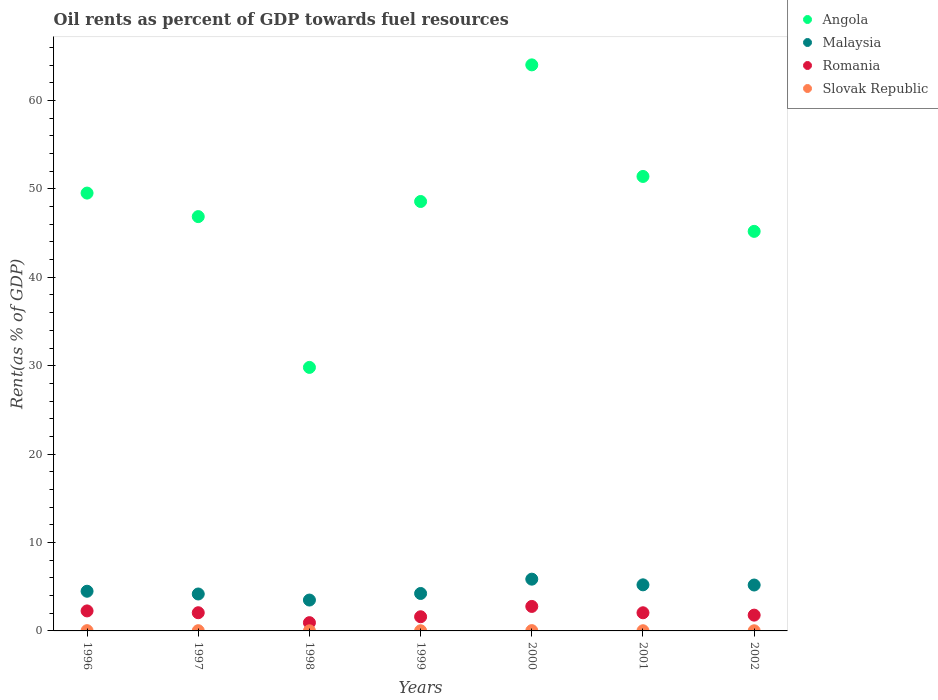How many different coloured dotlines are there?
Provide a short and direct response. 4. What is the oil rent in Romania in 1996?
Make the answer very short. 2.26. Across all years, what is the maximum oil rent in Malaysia?
Your answer should be very brief. 5.85. Across all years, what is the minimum oil rent in Slovak Republic?
Your response must be concise. 0.01. In which year was the oil rent in Angola minimum?
Your answer should be compact. 1998. What is the total oil rent in Romania in the graph?
Give a very brief answer. 13.47. What is the difference between the oil rent in Malaysia in 1997 and that in 1999?
Your answer should be compact. -0.06. What is the difference between the oil rent in Angola in 2002 and the oil rent in Slovak Republic in 1996?
Your response must be concise. 45.17. What is the average oil rent in Malaysia per year?
Provide a short and direct response. 4.66. In the year 2002, what is the difference between the oil rent in Romania and oil rent in Malaysia?
Provide a short and direct response. -3.41. In how many years, is the oil rent in Angola greater than 40 %?
Provide a short and direct response. 6. What is the ratio of the oil rent in Malaysia in 1998 to that in 2000?
Keep it short and to the point. 0.6. Is the difference between the oil rent in Romania in 1999 and 2002 greater than the difference between the oil rent in Malaysia in 1999 and 2002?
Provide a short and direct response. Yes. What is the difference between the highest and the second highest oil rent in Slovak Republic?
Offer a terse response. 0. What is the difference between the highest and the lowest oil rent in Slovak Republic?
Offer a very short reply. 0.02. Is it the case that in every year, the sum of the oil rent in Slovak Republic and oil rent in Romania  is greater than the sum of oil rent in Malaysia and oil rent in Angola?
Offer a terse response. No. Does the oil rent in Slovak Republic monotonically increase over the years?
Offer a very short reply. No. Is the oil rent in Slovak Republic strictly less than the oil rent in Romania over the years?
Provide a short and direct response. Yes. How many dotlines are there?
Ensure brevity in your answer.  4. Are the values on the major ticks of Y-axis written in scientific E-notation?
Offer a very short reply. No. Does the graph contain any zero values?
Offer a terse response. No. How many legend labels are there?
Provide a short and direct response. 4. What is the title of the graph?
Your response must be concise. Oil rents as percent of GDP towards fuel resources. Does "Iraq" appear as one of the legend labels in the graph?
Provide a succinct answer. No. What is the label or title of the X-axis?
Your answer should be very brief. Years. What is the label or title of the Y-axis?
Give a very brief answer. Rent(as % of GDP). What is the Rent(as % of GDP) of Angola in 1996?
Ensure brevity in your answer.  49.53. What is the Rent(as % of GDP) in Malaysia in 1996?
Offer a very short reply. 4.49. What is the Rent(as % of GDP) in Romania in 1996?
Your response must be concise. 2.26. What is the Rent(as % of GDP) in Slovak Republic in 1996?
Make the answer very short. 0.03. What is the Rent(as % of GDP) of Angola in 1997?
Provide a short and direct response. 46.87. What is the Rent(as % of GDP) in Malaysia in 1997?
Your answer should be very brief. 4.18. What is the Rent(as % of GDP) in Romania in 1997?
Your response must be concise. 2.06. What is the Rent(as % of GDP) of Slovak Republic in 1997?
Give a very brief answer. 0.03. What is the Rent(as % of GDP) in Angola in 1998?
Offer a terse response. 29.81. What is the Rent(as % of GDP) of Malaysia in 1998?
Your answer should be very brief. 3.49. What is the Rent(as % of GDP) in Romania in 1998?
Your answer should be compact. 0.93. What is the Rent(as % of GDP) of Slovak Republic in 1998?
Ensure brevity in your answer.  0.01. What is the Rent(as % of GDP) in Angola in 1999?
Ensure brevity in your answer.  48.58. What is the Rent(as % of GDP) of Malaysia in 1999?
Make the answer very short. 4.24. What is the Rent(as % of GDP) in Romania in 1999?
Your answer should be very brief. 1.6. What is the Rent(as % of GDP) in Slovak Republic in 1999?
Keep it short and to the point. 0.02. What is the Rent(as % of GDP) of Angola in 2000?
Offer a very short reply. 64.03. What is the Rent(as % of GDP) of Malaysia in 2000?
Give a very brief answer. 5.85. What is the Rent(as % of GDP) of Romania in 2000?
Offer a terse response. 2.77. What is the Rent(as % of GDP) of Slovak Republic in 2000?
Your answer should be very brief. 0.03. What is the Rent(as % of GDP) of Angola in 2001?
Make the answer very short. 51.41. What is the Rent(as % of GDP) in Malaysia in 2001?
Ensure brevity in your answer.  5.21. What is the Rent(as % of GDP) in Romania in 2001?
Make the answer very short. 2.05. What is the Rent(as % of GDP) of Slovak Republic in 2001?
Keep it short and to the point. 0.02. What is the Rent(as % of GDP) of Angola in 2002?
Make the answer very short. 45.2. What is the Rent(as % of GDP) in Malaysia in 2002?
Keep it short and to the point. 5.19. What is the Rent(as % of GDP) in Romania in 2002?
Keep it short and to the point. 1.79. What is the Rent(as % of GDP) of Slovak Republic in 2002?
Offer a terse response. 0.02. Across all years, what is the maximum Rent(as % of GDP) in Angola?
Keep it short and to the point. 64.03. Across all years, what is the maximum Rent(as % of GDP) of Malaysia?
Offer a very short reply. 5.85. Across all years, what is the maximum Rent(as % of GDP) of Romania?
Your response must be concise. 2.77. Across all years, what is the maximum Rent(as % of GDP) of Slovak Republic?
Provide a short and direct response. 0.03. Across all years, what is the minimum Rent(as % of GDP) of Angola?
Offer a terse response. 29.81. Across all years, what is the minimum Rent(as % of GDP) of Malaysia?
Provide a succinct answer. 3.49. Across all years, what is the minimum Rent(as % of GDP) in Romania?
Make the answer very short. 0.93. Across all years, what is the minimum Rent(as % of GDP) of Slovak Republic?
Your answer should be compact. 0.01. What is the total Rent(as % of GDP) in Angola in the graph?
Keep it short and to the point. 335.41. What is the total Rent(as % of GDP) of Malaysia in the graph?
Your response must be concise. 32.65. What is the total Rent(as % of GDP) in Romania in the graph?
Your response must be concise. 13.47. What is the total Rent(as % of GDP) in Slovak Republic in the graph?
Your answer should be very brief. 0.16. What is the difference between the Rent(as % of GDP) in Angola in 1996 and that in 1997?
Give a very brief answer. 2.66. What is the difference between the Rent(as % of GDP) in Malaysia in 1996 and that in 1997?
Your answer should be compact. 0.31. What is the difference between the Rent(as % of GDP) of Romania in 1996 and that in 1997?
Make the answer very short. 0.21. What is the difference between the Rent(as % of GDP) of Slovak Republic in 1996 and that in 1997?
Ensure brevity in your answer.  0. What is the difference between the Rent(as % of GDP) in Angola in 1996 and that in 1998?
Offer a terse response. 19.72. What is the difference between the Rent(as % of GDP) in Malaysia in 1996 and that in 1998?
Ensure brevity in your answer.  1. What is the difference between the Rent(as % of GDP) of Romania in 1996 and that in 1998?
Provide a short and direct response. 1.33. What is the difference between the Rent(as % of GDP) of Slovak Republic in 1996 and that in 1998?
Provide a succinct answer. 0.02. What is the difference between the Rent(as % of GDP) of Angola in 1996 and that in 1999?
Make the answer very short. 0.95. What is the difference between the Rent(as % of GDP) of Malaysia in 1996 and that in 1999?
Provide a short and direct response. 0.25. What is the difference between the Rent(as % of GDP) in Romania in 1996 and that in 1999?
Make the answer very short. 0.66. What is the difference between the Rent(as % of GDP) of Slovak Republic in 1996 and that in 1999?
Your response must be concise. 0.01. What is the difference between the Rent(as % of GDP) of Angola in 1996 and that in 2000?
Give a very brief answer. -14.5. What is the difference between the Rent(as % of GDP) in Malaysia in 1996 and that in 2000?
Ensure brevity in your answer.  -1.37. What is the difference between the Rent(as % of GDP) in Romania in 1996 and that in 2000?
Ensure brevity in your answer.  -0.51. What is the difference between the Rent(as % of GDP) of Slovak Republic in 1996 and that in 2000?
Keep it short and to the point. -0. What is the difference between the Rent(as % of GDP) in Angola in 1996 and that in 2001?
Your response must be concise. -1.88. What is the difference between the Rent(as % of GDP) of Malaysia in 1996 and that in 2001?
Make the answer very short. -0.72. What is the difference between the Rent(as % of GDP) of Romania in 1996 and that in 2001?
Provide a short and direct response. 0.21. What is the difference between the Rent(as % of GDP) of Slovak Republic in 1996 and that in 2001?
Give a very brief answer. 0.01. What is the difference between the Rent(as % of GDP) in Angola in 1996 and that in 2002?
Make the answer very short. 4.33. What is the difference between the Rent(as % of GDP) in Malaysia in 1996 and that in 2002?
Your response must be concise. -0.7. What is the difference between the Rent(as % of GDP) of Romania in 1996 and that in 2002?
Offer a very short reply. 0.48. What is the difference between the Rent(as % of GDP) in Slovak Republic in 1996 and that in 2002?
Your answer should be very brief. 0.01. What is the difference between the Rent(as % of GDP) of Angola in 1997 and that in 1998?
Offer a very short reply. 17.06. What is the difference between the Rent(as % of GDP) of Malaysia in 1997 and that in 1998?
Ensure brevity in your answer.  0.69. What is the difference between the Rent(as % of GDP) in Romania in 1997 and that in 1998?
Your answer should be very brief. 1.12. What is the difference between the Rent(as % of GDP) of Slovak Republic in 1997 and that in 1998?
Provide a short and direct response. 0.01. What is the difference between the Rent(as % of GDP) of Angola in 1997 and that in 1999?
Ensure brevity in your answer.  -1.71. What is the difference between the Rent(as % of GDP) in Malaysia in 1997 and that in 1999?
Your answer should be very brief. -0.06. What is the difference between the Rent(as % of GDP) of Romania in 1997 and that in 1999?
Provide a succinct answer. 0.46. What is the difference between the Rent(as % of GDP) of Slovak Republic in 1997 and that in 1999?
Ensure brevity in your answer.  0.01. What is the difference between the Rent(as % of GDP) of Angola in 1997 and that in 2000?
Your answer should be compact. -17.16. What is the difference between the Rent(as % of GDP) of Malaysia in 1997 and that in 2000?
Your answer should be compact. -1.68. What is the difference between the Rent(as % of GDP) of Romania in 1997 and that in 2000?
Provide a short and direct response. -0.71. What is the difference between the Rent(as % of GDP) of Slovak Republic in 1997 and that in 2000?
Your response must be concise. -0.01. What is the difference between the Rent(as % of GDP) in Angola in 1997 and that in 2001?
Offer a very short reply. -4.54. What is the difference between the Rent(as % of GDP) in Malaysia in 1997 and that in 2001?
Provide a short and direct response. -1.04. What is the difference between the Rent(as % of GDP) in Romania in 1997 and that in 2001?
Offer a very short reply. 0. What is the difference between the Rent(as % of GDP) in Slovak Republic in 1997 and that in 2001?
Offer a terse response. 0. What is the difference between the Rent(as % of GDP) of Angola in 1997 and that in 2002?
Keep it short and to the point. 1.67. What is the difference between the Rent(as % of GDP) in Malaysia in 1997 and that in 2002?
Your answer should be compact. -1.02. What is the difference between the Rent(as % of GDP) in Romania in 1997 and that in 2002?
Provide a short and direct response. 0.27. What is the difference between the Rent(as % of GDP) of Slovak Republic in 1997 and that in 2002?
Keep it short and to the point. 0.01. What is the difference between the Rent(as % of GDP) of Angola in 1998 and that in 1999?
Make the answer very short. -18.77. What is the difference between the Rent(as % of GDP) of Malaysia in 1998 and that in 1999?
Ensure brevity in your answer.  -0.74. What is the difference between the Rent(as % of GDP) in Romania in 1998 and that in 1999?
Offer a very short reply. -0.67. What is the difference between the Rent(as % of GDP) in Slovak Republic in 1998 and that in 1999?
Make the answer very short. -0.01. What is the difference between the Rent(as % of GDP) in Angola in 1998 and that in 2000?
Give a very brief answer. -34.22. What is the difference between the Rent(as % of GDP) of Malaysia in 1998 and that in 2000?
Make the answer very short. -2.36. What is the difference between the Rent(as % of GDP) of Romania in 1998 and that in 2000?
Your answer should be very brief. -1.83. What is the difference between the Rent(as % of GDP) of Slovak Republic in 1998 and that in 2000?
Keep it short and to the point. -0.02. What is the difference between the Rent(as % of GDP) of Angola in 1998 and that in 2001?
Make the answer very short. -21.6. What is the difference between the Rent(as % of GDP) of Malaysia in 1998 and that in 2001?
Ensure brevity in your answer.  -1.72. What is the difference between the Rent(as % of GDP) in Romania in 1998 and that in 2001?
Provide a short and direct response. -1.12. What is the difference between the Rent(as % of GDP) in Slovak Republic in 1998 and that in 2001?
Offer a very short reply. -0.01. What is the difference between the Rent(as % of GDP) of Angola in 1998 and that in 2002?
Your response must be concise. -15.39. What is the difference between the Rent(as % of GDP) of Malaysia in 1998 and that in 2002?
Ensure brevity in your answer.  -1.7. What is the difference between the Rent(as % of GDP) of Romania in 1998 and that in 2002?
Give a very brief answer. -0.85. What is the difference between the Rent(as % of GDP) in Slovak Republic in 1998 and that in 2002?
Make the answer very short. -0.01. What is the difference between the Rent(as % of GDP) in Angola in 1999 and that in 2000?
Give a very brief answer. -15.45. What is the difference between the Rent(as % of GDP) of Malaysia in 1999 and that in 2000?
Your answer should be very brief. -1.62. What is the difference between the Rent(as % of GDP) of Romania in 1999 and that in 2000?
Offer a very short reply. -1.17. What is the difference between the Rent(as % of GDP) of Slovak Republic in 1999 and that in 2000?
Provide a short and direct response. -0.01. What is the difference between the Rent(as % of GDP) of Angola in 1999 and that in 2001?
Your response must be concise. -2.83. What is the difference between the Rent(as % of GDP) of Malaysia in 1999 and that in 2001?
Provide a short and direct response. -0.98. What is the difference between the Rent(as % of GDP) in Romania in 1999 and that in 2001?
Provide a succinct answer. -0.45. What is the difference between the Rent(as % of GDP) of Slovak Republic in 1999 and that in 2001?
Ensure brevity in your answer.  -0. What is the difference between the Rent(as % of GDP) of Angola in 1999 and that in 2002?
Provide a succinct answer. 3.38. What is the difference between the Rent(as % of GDP) in Malaysia in 1999 and that in 2002?
Give a very brief answer. -0.96. What is the difference between the Rent(as % of GDP) of Romania in 1999 and that in 2002?
Provide a short and direct response. -0.18. What is the difference between the Rent(as % of GDP) in Slovak Republic in 1999 and that in 2002?
Offer a very short reply. 0. What is the difference between the Rent(as % of GDP) in Angola in 2000 and that in 2001?
Offer a terse response. 12.62. What is the difference between the Rent(as % of GDP) of Malaysia in 2000 and that in 2001?
Your response must be concise. 0.64. What is the difference between the Rent(as % of GDP) of Romania in 2000 and that in 2001?
Provide a short and direct response. 0.72. What is the difference between the Rent(as % of GDP) of Slovak Republic in 2000 and that in 2001?
Your response must be concise. 0.01. What is the difference between the Rent(as % of GDP) in Angola in 2000 and that in 2002?
Your response must be concise. 18.83. What is the difference between the Rent(as % of GDP) in Malaysia in 2000 and that in 2002?
Offer a terse response. 0.66. What is the difference between the Rent(as % of GDP) in Romania in 2000 and that in 2002?
Keep it short and to the point. 0.98. What is the difference between the Rent(as % of GDP) of Slovak Republic in 2000 and that in 2002?
Provide a succinct answer. 0.02. What is the difference between the Rent(as % of GDP) of Angola in 2001 and that in 2002?
Provide a short and direct response. 6.21. What is the difference between the Rent(as % of GDP) of Malaysia in 2001 and that in 2002?
Your answer should be very brief. 0.02. What is the difference between the Rent(as % of GDP) of Romania in 2001 and that in 2002?
Ensure brevity in your answer.  0.27. What is the difference between the Rent(as % of GDP) of Slovak Republic in 2001 and that in 2002?
Your answer should be very brief. 0. What is the difference between the Rent(as % of GDP) in Angola in 1996 and the Rent(as % of GDP) in Malaysia in 1997?
Your answer should be very brief. 45.35. What is the difference between the Rent(as % of GDP) of Angola in 1996 and the Rent(as % of GDP) of Romania in 1997?
Your response must be concise. 47.47. What is the difference between the Rent(as % of GDP) of Angola in 1996 and the Rent(as % of GDP) of Slovak Republic in 1997?
Your answer should be very brief. 49.5. What is the difference between the Rent(as % of GDP) of Malaysia in 1996 and the Rent(as % of GDP) of Romania in 1997?
Make the answer very short. 2.43. What is the difference between the Rent(as % of GDP) of Malaysia in 1996 and the Rent(as % of GDP) of Slovak Republic in 1997?
Offer a very short reply. 4.46. What is the difference between the Rent(as % of GDP) of Romania in 1996 and the Rent(as % of GDP) of Slovak Republic in 1997?
Ensure brevity in your answer.  2.24. What is the difference between the Rent(as % of GDP) in Angola in 1996 and the Rent(as % of GDP) in Malaysia in 1998?
Keep it short and to the point. 46.03. What is the difference between the Rent(as % of GDP) of Angola in 1996 and the Rent(as % of GDP) of Romania in 1998?
Your answer should be very brief. 48.59. What is the difference between the Rent(as % of GDP) in Angola in 1996 and the Rent(as % of GDP) in Slovak Republic in 1998?
Give a very brief answer. 49.51. What is the difference between the Rent(as % of GDP) in Malaysia in 1996 and the Rent(as % of GDP) in Romania in 1998?
Make the answer very short. 3.55. What is the difference between the Rent(as % of GDP) in Malaysia in 1996 and the Rent(as % of GDP) in Slovak Republic in 1998?
Your answer should be compact. 4.48. What is the difference between the Rent(as % of GDP) in Romania in 1996 and the Rent(as % of GDP) in Slovak Republic in 1998?
Provide a succinct answer. 2.25. What is the difference between the Rent(as % of GDP) in Angola in 1996 and the Rent(as % of GDP) in Malaysia in 1999?
Your answer should be very brief. 45.29. What is the difference between the Rent(as % of GDP) of Angola in 1996 and the Rent(as % of GDP) of Romania in 1999?
Provide a short and direct response. 47.92. What is the difference between the Rent(as % of GDP) of Angola in 1996 and the Rent(as % of GDP) of Slovak Republic in 1999?
Your answer should be very brief. 49.51. What is the difference between the Rent(as % of GDP) in Malaysia in 1996 and the Rent(as % of GDP) in Romania in 1999?
Provide a succinct answer. 2.89. What is the difference between the Rent(as % of GDP) in Malaysia in 1996 and the Rent(as % of GDP) in Slovak Republic in 1999?
Provide a short and direct response. 4.47. What is the difference between the Rent(as % of GDP) in Romania in 1996 and the Rent(as % of GDP) in Slovak Republic in 1999?
Keep it short and to the point. 2.24. What is the difference between the Rent(as % of GDP) in Angola in 1996 and the Rent(as % of GDP) in Malaysia in 2000?
Make the answer very short. 43.67. What is the difference between the Rent(as % of GDP) of Angola in 1996 and the Rent(as % of GDP) of Romania in 2000?
Your response must be concise. 46.76. What is the difference between the Rent(as % of GDP) in Angola in 1996 and the Rent(as % of GDP) in Slovak Republic in 2000?
Ensure brevity in your answer.  49.49. What is the difference between the Rent(as % of GDP) of Malaysia in 1996 and the Rent(as % of GDP) of Romania in 2000?
Provide a short and direct response. 1.72. What is the difference between the Rent(as % of GDP) of Malaysia in 1996 and the Rent(as % of GDP) of Slovak Republic in 2000?
Keep it short and to the point. 4.45. What is the difference between the Rent(as % of GDP) in Romania in 1996 and the Rent(as % of GDP) in Slovak Republic in 2000?
Give a very brief answer. 2.23. What is the difference between the Rent(as % of GDP) of Angola in 1996 and the Rent(as % of GDP) of Malaysia in 2001?
Your response must be concise. 44.31. What is the difference between the Rent(as % of GDP) of Angola in 1996 and the Rent(as % of GDP) of Romania in 2001?
Your answer should be compact. 47.47. What is the difference between the Rent(as % of GDP) of Angola in 1996 and the Rent(as % of GDP) of Slovak Republic in 2001?
Provide a short and direct response. 49.51. What is the difference between the Rent(as % of GDP) of Malaysia in 1996 and the Rent(as % of GDP) of Romania in 2001?
Provide a short and direct response. 2.44. What is the difference between the Rent(as % of GDP) of Malaysia in 1996 and the Rent(as % of GDP) of Slovak Republic in 2001?
Offer a terse response. 4.47. What is the difference between the Rent(as % of GDP) in Romania in 1996 and the Rent(as % of GDP) in Slovak Republic in 2001?
Ensure brevity in your answer.  2.24. What is the difference between the Rent(as % of GDP) in Angola in 1996 and the Rent(as % of GDP) in Malaysia in 2002?
Provide a succinct answer. 44.33. What is the difference between the Rent(as % of GDP) of Angola in 1996 and the Rent(as % of GDP) of Romania in 2002?
Provide a short and direct response. 47.74. What is the difference between the Rent(as % of GDP) in Angola in 1996 and the Rent(as % of GDP) in Slovak Republic in 2002?
Ensure brevity in your answer.  49.51. What is the difference between the Rent(as % of GDP) of Malaysia in 1996 and the Rent(as % of GDP) of Romania in 2002?
Provide a short and direct response. 2.7. What is the difference between the Rent(as % of GDP) in Malaysia in 1996 and the Rent(as % of GDP) in Slovak Republic in 2002?
Give a very brief answer. 4.47. What is the difference between the Rent(as % of GDP) in Romania in 1996 and the Rent(as % of GDP) in Slovak Republic in 2002?
Provide a succinct answer. 2.25. What is the difference between the Rent(as % of GDP) of Angola in 1997 and the Rent(as % of GDP) of Malaysia in 1998?
Give a very brief answer. 43.37. What is the difference between the Rent(as % of GDP) of Angola in 1997 and the Rent(as % of GDP) of Romania in 1998?
Your response must be concise. 45.93. What is the difference between the Rent(as % of GDP) in Angola in 1997 and the Rent(as % of GDP) in Slovak Republic in 1998?
Offer a terse response. 46.85. What is the difference between the Rent(as % of GDP) of Malaysia in 1997 and the Rent(as % of GDP) of Romania in 1998?
Make the answer very short. 3.24. What is the difference between the Rent(as % of GDP) in Malaysia in 1997 and the Rent(as % of GDP) in Slovak Republic in 1998?
Make the answer very short. 4.17. What is the difference between the Rent(as % of GDP) of Romania in 1997 and the Rent(as % of GDP) of Slovak Republic in 1998?
Your answer should be very brief. 2.05. What is the difference between the Rent(as % of GDP) in Angola in 1997 and the Rent(as % of GDP) in Malaysia in 1999?
Make the answer very short. 42.63. What is the difference between the Rent(as % of GDP) of Angola in 1997 and the Rent(as % of GDP) of Romania in 1999?
Provide a succinct answer. 45.26. What is the difference between the Rent(as % of GDP) in Angola in 1997 and the Rent(as % of GDP) in Slovak Republic in 1999?
Your answer should be compact. 46.85. What is the difference between the Rent(as % of GDP) in Malaysia in 1997 and the Rent(as % of GDP) in Romania in 1999?
Your response must be concise. 2.58. What is the difference between the Rent(as % of GDP) of Malaysia in 1997 and the Rent(as % of GDP) of Slovak Republic in 1999?
Your response must be concise. 4.16. What is the difference between the Rent(as % of GDP) of Romania in 1997 and the Rent(as % of GDP) of Slovak Republic in 1999?
Provide a succinct answer. 2.04. What is the difference between the Rent(as % of GDP) in Angola in 1997 and the Rent(as % of GDP) in Malaysia in 2000?
Make the answer very short. 41.01. What is the difference between the Rent(as % of GDP) in Angola in 1997 and the Rent(as % of GDP) in Romania in 2000?
Offer a very short reply. 44.1. What is the difference between the Rent(as % of GDP) in Angola in 1997 and the Rent(as % of GDP) in Slovak Republic in 2000?
Your answer should be compact. 46.83. What is the difference between the Rent(as % of GDP) in Malaysia in 1997 and the Rent(as % of GDP) in Romania in 2000?
Give a very brief answer. 1.41. What is the difference between the Rent(as % of GDP) of Malaysia in 1997 and the Rent(as % of GDP) of Slovak Republic in 2000?
Offer a very short reply. 4.14. What is the difference between the Rent(as % of GDP) in Romania in 1997 and the Rent(as % of GDP) in Slovak Republic in 2000?
Offer a terse response. 2.02. What is the difference between the Rent(as % of GDP) in Angola in 1997 and the Rent(as % of GDP) in Malaysia in 2001?
Offer a terse response. 41.65. What is the difference between the Rent(as % of GDP) of Angola in 1997 and the Rent(as % of GDP) of Romania in 2001?
Keep it short and to the point. 44.81. What is the difference between the Rent(as % of GDP) of Angola in 1997 and the Rent(as % of GDP) of Slovak Republic in 2001?
Give a very brief answer. 46.84. What is the difference between the Rent(as % of GDP) in Malaysia in 1997 and the Rent(as % of GDP) in Romania in 2001?
Give a very brief answer. 2.12. What is the difference between the Rent(as % of GDP) in Malaysia in 1997 and the Rent(as % of GDP) in Slovak Republic in 2001?
Offer a terse response. 4.16. What is the difference between the Rent(as % of GDP) in Romania in 1997 and the Rent(as % of GDP) in Slovak Republic in 2001?
Provide a succinct answer. 2.04. What is the difference between the Rent(as % of GDP) in Angola in 1997 and the Rent(as % of GDP) in Malaysia in 2002?
Offer a terse response. 41.67. What is the difference between the Rent(as % of GDP) of Angola in 1997 and the Rent(as % of GDP) of Romania in 2002?
Offer a very short reply. 45.08. What is the difference between the Rent(as % of GDP) of Angola in 1997 and the Rent(as % of GDP) of Slovak Republic in 2002?
Your answer should be very brief. 46.85. What is the difference between the Rent(as % of GDP) of Malaysia in 1997 and the Rent(as % of GDP) of Romania in 2002?
Provide a succinct answer. 2.39. What is the difference between the Rent(as % of GDP) of Malaysia in 1997 and the Rent(as % of GDP) of Slovak Republic in 2002?
Give a very brief answer. 4.16. What is the difference between the Rent(as % of GDP) in Romania in 1997 and the Rent(as % of GDP) in Slovak Republic in 2002?
Provide a succinct answer. 2.04. What is the difference between the Rent(as % of GDP) in Angola in 1998 and the Rent(as % of GDP) in Malaysia in 1999?
Your answer should be compact. 25.57. What is the difference between the Rent(as % of GDP) of Angola in 1998 and the Rent(as % of GDP) of Romania in 1999?
Provide a succinct answer. 28.21. What is the difference between the Rent(as % of GDP) in Angola in 1998 and the Rent(as % of GDP) in Slovak Republic in 1999?
Make the answer very short. 29.79. What is the difference between the Rent(as % of GDP) in Malaysia in 1998 and the Rent(as % of GDP) in Romania in 1999?
Ensure brevity in your answer.  1.89. What is the difference between the Rent(as % of GDP) in Malaysia in 1998 and the Rent(as % of GDP) in Slovak Republic in 1999?
Your answer should be compact. 3.47. What is the difference between the Rent(as % of GDP) of Romania in 1998 and the Rent(as % of GDP) of Slovak Republic in 1999?
Your answer should be compact. 0.92. What is the difference between the Rent(as % of GDP) of Angola in 1998 and the Rent(as % of GDP) of Malaysia in 2000?
Provide a short and direct response. 23.95. What is the difference between the Rent(as % of GDP) in Angola in 1998 and the Rent(as % of GDP) in Romania in 2000?
Offer a very short reply. 27.04. What is the difference between the Rent(as % of GDP) in Angola in 1998 and the Rent(as % of GDP) in Slovak Republic in 2000?
Offer a very short reply. 29.77. What is the difference between the Rent(as % of GDP) of Malaysia in 1998 and the Rent(as % of GDP) of Romania in 2000?
Make the answer very short. 0.72. What is the difference between the Rent(as % of GDP) in Malaysia in 1998 and the Rent(as % of GDP) in Slovak Republic in 2000?
Offer a terse response. 3.46. What is the difference between the Rent(as % of GDP) of Romania in 1998 and the Rent(as % of GDP) of Slovak Republic in 2000?
Your answer should be very brief. 0.9. What is the difference between the Rent(as % of GDP) in Angola in 1998 and the Rent(as % of GDP) in Malaysia in 2001?
Provide a short and direct response. 24.6. What is the difference between the Rent(as % of GDP) of Angola in 1998 and the Rent(as % of GDP) of Romania in 2001?
Ensure brevity in your answer.  27.76. What is the difference between the Rent(as % of GDP) in Angola in 1998 and the Rent(as % of GDP) in Slovak Republic in 2001?
Ensure brevity in your answer.  29.79. What is the difference between the Rent(as % of GDP) of Malaysia in 1998 and the Rent(as % of GDP) of Romania in 2001?
Make the answer very short. 1.44. What is the difference between the Rent(as % of GDP) of Malaysia in 1998 and the Rent(as % of GDP) of Slovak Republic in 2001?
Give a very brief answer. 3.47. What is the difference between the Rent(as % of GDP) of Romania in 1998 and the Rent(as % of GDP) of Slovak Republic in 2001?
Keep it short and to the point. 0.91. What is the difference between the Rent(as % of GDP) of Angola in 1998 and the Rent(as % of GDP) of Malaysia in 2002?
Your answer should be compact. 24.62. What is the difference between the Rent(as % of GDP) in Angola in 1998 and the Rent(as % of GDP) in Romania in 2002?
Keep it short and to the point. 28.02. What is the difference between the Rent(as % of GDP) in Angola in 1998 and the Rent(as % of GDP) in Slovak Republic in 2002?
Give a very brief answer. 29.79. What is the difference between the Rent(as % of GDP) in Malaysia in 1998 and the Rent(as % of GDP) in Romania in 2002?
Offer a very short reply. 1.71. What is the difference between the Rent(as % of GDP) of Malaysia in 1998 and the Rent(as % of GDP) of Slovak Republic in 2002?
Offer a very short reply. 3.47. What is the difference between the Rent(as % of GDP) in Romania in 1998 and the Rent(as % of GDP) in Slovak Republic in 2002?
Give a very brief answer. 0.92. What is the difference between the Rent(as % of GDP) of Angola in 1999 and the Rent(as % of GDP) of Malaysia in 2000?
Your answer should be very brief. 42.72. What is the difference between the Rent(as % of GDP) of Angola in 1999 and the Rent(as % of GDP) of Romania in 2000?
Make the answer very short. 45.81. What is the difference between the Rent(as % of GDP) of Angola in 1999 and the Rent(as % of GDP) of Slovak Republic in 2000?
Offer a terse response. 48.54. What is the difference between the Rent(as % of GDP) of Malaysia in 1999 and the Rent(as % of GDP) of Romania in 2000?
Your answer should be compact. 1.47. What is the difference between the Rent(as % of GDP) of Malaysia in 1999 and the Rent(as % of GDP) of Slovak Republic in 2000?
Your answer should be very brief. 4.2. What is the difference between the Rent(as % of GDP) of Romania in 1999 and the Rent(as % of GDP) of Slovak Republic in 2000?
Your answer should be very brief. 1.57. What is the difference between the Rent(as % of GDP) of Angola in 1999 and the Rent(as % of GDP) of Malaysia in 2001?
Make the answer very short. 43.36. What is the difference between the Rent(as % of GDP) in Angola in 1999 and the Rent(as % of GDP) in Romania in 2001?
Ensure brevity in your answer.  46.52. What is the difference between the Rent(as % of GDP) in Angola in 1999 and the Rent(as % of GDP) in Slovak Republic in 2001?
Your answer should be very brief. 48.55. What is the difference between the Rent(as % of GDP) of Malaysia in 1999 and the Rent(as % of GDP) of Romania in 2001?
Provide a succinct answer. 2.18. What is the difference between the Rent(as % of GDP) in Malaysia in 1999 and the Rent(as % of GDP) in Slovak Republic in 2001?
Offer a terse response. 4.21. What is the difference between the Rent(as % of GDP) in Romania in 1999 and the Rent(as % of GDP) in Slovak Republic in 2001?
Provide a short and direct response. 1.58. What is the difference between the Rent(as % of GDP) in Angola in 1999 and the Rent(as % of GDP) in Malaysia in 2002?
Ensure brevity in your answer.  43.38. What is the difference between the Rent(as % of GDP) of Angola in 1999 and the Rent(as % of GDP) of Romania in 2002?
Provide a short and direct response. 46.79. What is the difference between the Rent(as % of GDP) of Angola in 1999 and the Rent(as % of GDP) of Slovak Republic in 2002?
Offer a very short reply. 48.56. What is the difference between the Rent(as % of GDP) in Malaysia in 1999 and the Rent(as % of GDP) in Romania in 2002?
Keep it short and to the point. 2.45. What is the difference between the Rent(as % of GDP) of Malaysia in 1999 and the Rent(as % of GDP) of Slovak Republic in 2002?
Your response must be concise. 4.22. What is the difference between the Rent(as % of GDP) in Romania in 1999 and the Rent(as % of GDP) in Slovak Republic in 2002?
Ensure brevity in your answer.  1.58. What is the difference between the Rent(as % of GDP) of Angola in 2000 and the Rent(as % of GDP) of Malaysia in 2001?
Make the answer very short. 58.82. What is the difference between the Rent(as % of GDP) of Angola in 2000 and the Rent(as % of GDP) of Romania in 2001?
Give a very brief answer. 61.98. What is the difference between the Rent(as % of GDP) in Angola in 2000 and the Rent(as % of GDP) in Slovak Republic in 2001?
Your answer should be very brief. 64.01. What is the difference between the Rent(as % of GDP) of Malaysia in 2000 and the Rent(as % of GDP) of Romania in 2001?
Provide a short and direct response. 3.8. What is the difference between the Rent(as % of GDP) of Malaysia in 2000 and the Rent(as % of GDP) of Slovak Republic in 2001?
Make the answer very short. 5.83. What is the difference between the Rent(as % of GDP) of Romania in 2000 and the Rent(as % of GDP) of Slovak Republic in 2001?
Provide a succinct answer. 2.75. What is the difference between the Rent(as % of GDP) in Angola in 2000 and the Rent(as % of GDP) in Malaysia in 2002?
Give a very brief answer. 58.84. What is the difference between the Rent(as % of GDP) of Angola in 2000 and the Rent(as % of GDP) of Romania in 2002?
Your response must be concise. 62.24. What is the difference between the Rent(as % of GDP) of Angola in 2000 and the Rent(as % of GDP) of Slovak Republic in 2002?
Provide a short and direct response. 64.01. What is the difference between the Rent(as % of GDP) of Malaysia in 2000 and the Rent(as % of GDP) of Romania in 2002?
Give a very brief answer. 4.07. What is the difference between the Rent(as % of GDP) in Malaysia in 2000 and the Rent(as % of GDP) in Slovak Republic in 2002?
Keep it short and to the point. 5.84. What is the difference between the Rent(as % of GDP) in Romania in 2000 and the Rent(as % of GDP) in Slovak Republic in 2002?
Give a very brief answer. 2.75. What is the difference between the Rent(as % of GDP) in Angola in 2001 and the Rent(as % of GDP) in Malaysia in 2002?
Offer a terse response. 46.22. What is the difference between the Rent(as % of GDP) of Angola in 2001 and the Rent(as % of GDP) of Romania in 2002?
Offer a terse response. 49.62. What is the difference between the Rent(as % of GDP) in Angola in 2001 and the Rent(as % of GDP) in Slovak Republic in 2002?
Make the answer very short. 51.39. What is the difference between the Rent(as % of GDP) in Malaysia in 2001 and the Rent(as % of GDP) in Romania in 2002?
Give a very brief answer. 3.43. What is the difference between the Rent(as % of GDP) in Malaysia in 2001 and the Rent(as % of GDP) in Slovak Republic in 2002?
Offer a very short reply. 5.2. What is the difference between the Rent(as % of GDP) in Romania in 2001 and the Rent(as % of GDP) in Slovak Republic in 2002?
Your response must be concise. 2.04. What is the average Rent(as % of GDP) of Angola per year?
Provide a short and direct response. 47.92. What is the average Rent(as % of GDP) in Malaysia per year?
Keep it short and to the point. 4.66. What is the average Rent(as % of GDP) of Romania per year?
Offer a terse response. 1.92. What is the average Rent(as % of GDP) in Slovak Republic per year?
Your answer should be very brief. 0.02. In the year 1996, what is the difference between the Rent(as % of GDP) of Angola and Rent(as % of GDP) of Malaysia?
Ensure brevity in your answer.  45.04. In the year 1996, what is the difference between the Rent(as % of GDP) of Angola and Rent(as % of GDP) of Romania?
Your answer should be compact. 47.26. In the year 1996, what is the difference between the Rent(as % of GDP) of Angola and Rent(as % of GDP) of Slovak Republic?
Offer a very short reply. 49.5. In the year 1996, what is the difference between the Rent(as % of GDP) of Malaysia and Rent(as % of GDP) of Romania?
Offer a very short reply. 2.23. In the year 1996, what is the difference between the Rent(as % of GDP) in Malaysia and Rent(as % of GDP) in Slovak Republic?
Provide a succinct answer. 4.46. In the year 1996, what is the difference between the Rent(as % of GDP) of Romania and Rent(as % of GDP) of Slovak Republic?
Your response must be concise. 2.23. In the year 1997, what is the difference between the Rent(as % of GDP) of Angola and Rent(as % of GDP) of Malaysia?
Your answer should be compact. 42.69. In the year 1997, what is the difference between the Rent(as % of GDP) in Angola and Rent(as % of GDP) in Romania?
Keep it short and to the point. 44.81. In the year 1997, what is the difference between the Rent(as % of GDP) of Angola and Rent(as % of GDP) of Slovak Republic?
Your answer should be very brief. 46.84. In the year 1997, what is the difference between the Rent(as % of GDP) of Malaysia and Rent(as % of GDP) of Romania?
Provide a short and direct response. 2.12. In the year 1997, what is the difference between the Rent(as % of GDP) in Malaysia and Rent(as % of GDP) in Slovak Republic?
Ensure brevity in your answer.  4.15. In the year 1997, what is the difference between the Rent(as % of GDP) in Romania and Rent(as % of GDP) in Slovak Republic?
Offer a terse response. 2.03. In the year 1998, what is the difference between the Rent(as % of GDP) in Angola and Rent(as % of GDP) in Malaysia?
Offer a very short reply. 26.32. In the year 1998, what is the difference between the Rent(as % of GDP) in Angola and Rent(as % of GDP) in Romania?
Make the answer very short. 28.87. In the year 1998, what is the difference between the Rent(as % of GDP) in Angola and Rent(as % of GDP) in Slovak Republic?
Ensure brevity in your answer.  29.8. In the year 1998, what is the difference between the Rent(as % of GDP) of Malaysia and Rent(as % of GDP) of Romania?
Offer a very short reply. 2.56. In the year 1998, what is the difference between the Rent(as % of GDP) in Malaysia and Rent(as % of GDP) in Slovak Republic?
Provide a short and direct response. 3.48. In the year 1998, what is the difference between the Rent(as % of GDP) of Romania and Rent(as % of GDP) of Slovak Republic?
Ensure brevity in your answer.  0.92. In the year 1999, what is the difference between the Rent(as % of GDP) of Angola and Rent(as % of GDP) of Malaysia?
Your answer should be compact. 44.34. In the year 1999, what is the difference between the Rent(as % of GDP) of Angola and Rent(as % of GDP) of Romania?
Your response must be concise. 46.97. In the year 1999, what is the difference between the Rent(as % of GDP) of Angola and Rent(as % of GDP) of Slovak Republic?
Ensure brevity in your answer.  48.56. In the year 1999, what is the difference between the Rent(as % of GDP) in Malaysia and Rent(as % of GDP) in Romania?
Ensure brevity in your answer.  2.63. In the year 1999, what is the difference between the Rent(as % of GDP) of Malaysia and Rent(as % of GDP) of Slovak Republic?
Offer a very short reply. 4.22. In the year 1999, what is the difference between the Rent(as % of GDP) in Romania and Rent(as % of GDP) in Slovak Republic?
Offer a terse response. 1.58. In the year 2000, what is the difference between the Rent(as % of GDP) of Angola and Rent(as % of GDP) of Malaysia?
Make the answer very short. 58.17. In the year 2000, what is the difference between the Rent(as % of GDP) in Angola and Rent(as % of GDP) in Romania?
Keep it short and to the point. 61.26. In the year 2000, what is the difference between the Rent(as % of GDP) of Angola and Rent(as % of GDP) of Slovak Republic?
Your answer should be compact. 63.99. In the year 2000, what is the difference between the Rent(as % of GDP) in Malaysia and Rent(as % of GDP) in Romania?
Make the answer very short. 3.08. In the year 2000, what is the difference between the Rent(as % of GDP) in Malaysia and Rent(as % of GDP) in Slovak Republic?
Offer a very short reply. 5.82. In the year 2000, what is the difference between the Rent(as % of GDP) of Romania and Rent(as % of GDP) of Slovak Republic?
Keep it short and to the point. 2.74. In the year 2001, what is the difference between the Rent(as % of GDP) of Angola and Rent(as % of GDP) of Malaysia?
Make the answer very short. 46.2. In the year 2001, what is the difference between the Rent(as % of GDP) in Angola and Rent(as % of GDP) in Romania?
Your answer should be very brief. 49.36. In the year 2001, what is the difference between the Rent(as % of GDP) of Angola and Rent(as % of GDP) of Slovak Republic?
Make the answer very short. 51.39. In the year 2001, what is the difference between the Rent(as % of GDP) in Malaysia and Rent(as % of GDP) in Romania?
Your response must be concise. 3.16. In the year 2001, what is the difference between the Rent(as % of GDP) of Malaysia and Rent(as % of GDP) of Slovak Republic?
Your answer should be compact. 5.19. In the year 2001, what is the difference between the Rent(as % of GDP) in Romania and Rent(as % of GDP) in Slovak Republic?
Your response must be concise. 2.03. In the year 2002, what is the difference between the Rent(as % of GDP) in Angola and Rent(as % of GDP) in Malaysia?
Ensure brevity in your answer.  40. In the year 2002, what is the difference between the Rent(as % of GDP) of Angola and Rent(as % of GDP) of Romania?
Provide a short and direct response. 43.41. In the year 2002, what is the difference between the Rent(as % of GDP) of Angola and Rent(as % of GDP) of Slovak Republic?
Provide a short and direct response. 45.18. In the year 2002, what is the difference between the Rent(as % of GDP) of Malaysia and Rent(as % of GDP) of Romania?
Provide a succinct answer. 3.41. In the year 2002, what is the difference between the Rent(as % of GDP) of Malaysia and Rent(as % of GDP) of Slovak Republic?
Offer a very short reply. 5.18. In the year 2002, what is the difference between the Rent(as % of GDP) of Romania and Rent(as % of GDP) of Slovak Republic?
Ensure brevity in your answer.  1.77. What is the ratio of the Rent(as % of GDP) of Angola in 1996 to that in 1997?
Provide a short and direct response. 1.06. What is the ratio of the Rent(as % of GDP) of Malaysia in 1996 to that in 1997?
Offer a terse response. 1.07. What is the ratio of the Rent(as % of GDP) in Romania in 1996 to that in 1997?
Ensure brevity in your answer.  1.1. What is the ratio of the Rent(as % of GDP) of Slovak Republic in 1996 to that in 1997?
Ensure brevity in your answer.  1.19. What is the ratio of the Rent(as % of GDP) of Angola in 1996 to that in 1998?
Your answer should be very brief. 1.66. What is the ratio of the Rent(as % of GDP) in Malaysia in 1996 to that in 1998?
Your answer should be compact. 1.29. What is the ratio of the Rent(as % of GDP) of Romania in 1996 to that in 1998?
Keep it short and to the point. 2.42. What is the ratio of the Rent(as % of GDP) of Slovak Republic in 1996 to that in 1998?
Ensure brevity in your answer.  2.45. What is the ratio of the Rent(as % of GDP) in Angola in 1996 to that in 1999?
Offer a very short reply. 1.02. What is the ratio of the Rent(as % of GDP) of Malaysia in 1996 to that in 1999?
Give a very brief answer. 1.06. What is the ratio of the Rent(as % of GDP) in Romania in 1996 to that in 1999?
Offer a terse response. 1.41. What is the ratio of the Rent(as % of GDP) of Slovak Republic in 1996 to that in 1999?
Make the answer very short. 1.53. What is the ratio of the Rent(as % of GDP) of Angola in 1996 to that in 2000?
Offer a terse response. 0.77. What is the ratio of the Rent(as % of GDP) in Malaysia in 1996 to that in 2000?
Ensure brevity in your answer.  0.77. What is the ratio of the Rent(as % of GDP) in Romania in 1996 to that in 2000?
Offer a very short reply. 0.82. What is the ratio of the Rent(as % of GDP) of Slovak Republic in 1996 to that in 2000?
Make the answer very short. 0.89. What is the ratio of the Rent(as % of GDP) in Angola in 1996 to that in 2001?
Offer a terse response. 0.96. What is the ratio of the Rent(as % of GDP) in Malaysia in 1996 to that in 2001?
Ensure brevity in your answer.  0.86. What is the ratio of the Rent(as % of GDP) in Romania in 1996 to that in 2001?
Ensure brevity in your answer.  1.1. What is the ratio of the Rent(as % of GDP) in Slovak Republic in 1996 to that in 2001?
Ensure brevity in your answer.  1.48. What is the ratio of the Rent(as % of GDP) of Angola in 1996 to that in 2002?
Offer a very short reply. 1.1. What is the ratio of the Rent(as % of GDP) of Malaysia in 1996 to that in 2002?
Give a very brief answer. 0.86. What is the ratio of the Rent(as % of GDP) in Romania in 1996 to that in 2002?
Offer a very short reply. 1.27. What is the ratio of the Rent(as % of GDP) in Slovak Republic in 1996 to that in 2002?
Your answer should be very brief. 1.74. What is the ratio of the Rent(as % of GDP) of Angola in 1997 to that in 1998?
Your answer should be compact. 1.57. What is the ratio of the Rent(as % of GDP) of Malaysia in 1997 to that in 1998?
Provide a succinct answer. 1.2. What is the ratio of the Rent(as % of GDP) of Romania in 1997 to that in 1998?
Keep it short and to the point. 2.2. What is the ratio of the Rent(as % of GDP) in Slovak Republic in 1997 to that in 1998?
Make the answer very short. 2.05. What is the ratio of the Rent(as % of GDP) in Angola in 1997 to that in 1999?
Your response must be concise. 0.96. What is the ratio of the Rent(as % of GDP) of Malaysia in 1997 to that in 1999?
Your response must be concise. 0.99. What is the ratio of the Rent(as % of GDP) of Romania in 1997 to that in 1999?
Your answer should be very brief. 1.28. What is the ratio of the Rent(as % of GDP) in Slovak Republic in 1997 to that in 1999?
Give a very brief answer. 1.28. What is the ratio of the Rent(as % of GDP) of Angola in 1997 to that in 2000?
Offer a terse response. 0.73. What is the ratio of the Rent(as % of GDP) in Malaysia in 1997 to that in 2000?
Provide a succinct answer. 0.71. What is the ratio of the Rent(as % of GDP) of Romania in 1997 to that in 2000?
Provide a short and direct response. 0.74. What is the ratio of the Rent(as % of GDP) in Slovak Republic in 1997 to that in 2000?
Your answer should be very brief. 0.74. What is the ratio of the Rent(as % of GDP) in Angola in 1997 to that in 2001?
Keep it short and to the point. 0.91. What is the ratio of the Rent(as % of GDP) of Malaysia in 1997 to that in 2001?
Make the answer very short. 0.8. What is the ratio of the Rent(as % of GDP) in Romania in 1997 to that in 2001?
Offer a very short reply. 1. What is the ratio of the Rent(as % of GDP) in Slovak Republic in 1997 to that in 2001?
Ensure brevity in your answer.  1.24. What is the ratio of the Rent(as % of GDP) in Angola in 1997 to that in 2002?
Give a very brief answer. 1.04. What is the ratio of the Rent(as % of GDP) in Malaysia in 1997 to that in 2002?
Ensure brevity in your answer.  0.8. What is the ratio of the Rent(as % of GDP) of Romania in 1997 to that in 2002?
Your answer should be very brief. 1.15. What is the ratio of the Rent(as % of GDP) of Slovak Republic in 1997 to that in 2002?
Keep it short and to the point. 1.46. What is the ratio of the Rent(as % of GDP) in Angola in 1998 to that in 1999?
Give a very brief answer. 0.61. What is the ratio of the Rent(as % of GDP) in Malaysia in 1998 to that in 1999?
Make the answer very short. 0.82. What is the ratio of the Rent(as % of GDP) in Romania in 1998 to that in 1999?
Provide a short and direct response. 0.58. What is the ratio of the Rent(as % of GDP) in Slovak Republic in 1998 to that in 1999?
Keep it short and to the point. 0.62. What is the ratio of the Rent(as % of GDP) in Angola in 1998 to that in 2000?
Provide a succinct answer. 0.47. What is the ratio of the Rent(as % of GDP) in Malaysia in 1998 to that in 2000?
Offer a terse response. 0.6. What is the ratio of the Rent(as % of GDP) of Romania in 1998 to that in 2000?
Your answer should be compact. 0.34. What is the ratio of the Rent(as % of GDP) of Slovak Republic in 1998 to that in 2000?
Offer a terse response. 0.36. What is the ratio of the Rent(as % of GDP) in Angola in 1998 to that in 2001?
Offer a terse response. 0.58. What is the ratio of the Rent(as % of GDP) of Malaysia in 1998 to that in 2001?
Provide a succinct answer. 0.67. What is the ratio of the Rent(as % of GDP) in Romania in 1998 to that in 2001?
Provide a succinct answer. 0.46. What is the ratio of the Rent(as % of GDP) in Slovak Republic in 1998 to that in 2001?
Offer a terse response. 0.6. What is the ratio of the Rent(as % of GDP) of Angola in 1998 to that in 2002?
Ensure brevity in your answer.  0.66. What is the ratio of the Rent(as % of GDP) in Malaysia in 1998 to that in 2002?
Your answer should be very brief. 0.67. What is the ratio of the Rent(as % of GDP) in Romania in 1998 to that in 2002?
Your answer should be compact. 0.52. What is the ratio of the Rent(as % of GDP) of Slovak Republic in 1998 to that in 2002?
Offer a terse response. 0.71. What is the ratio of the Rent(as % of GDP) of Angola in 1999 to that in 2000?
Offer a terse response. 0.76. What is the ratio of the Rent(as % of GDP) in Malaysia in 1999 to that in 2000?
Provide a short and direct response. 0.72. What is the ratio of the Rent(as % of GDP) in Romania in 1999 to that in 2000?
Your answer should be very brief. 0.58. What is the ratio of the Rent(as % of GDP) in Slovak Republic in 1999 to that in 2000?
Ensure brevity in your answer.  0.58. What is the ratio of the Rent(as % of GDP) in Angola in 1999 to that in 2001?
Your response must be concise. 0.94. What is the ratio of the Rent(as % of GDP) of Malaysia in 1999 to that in 2001?
Your answer should be very brief. 0.81. What is the ratio of the Rent(as % of GDP) of Romania in 1999 to that in 2001?
Keep it short and to the point. 0.78. What is the ratio of the Rent(as % of GDP) of Slovak Republic in 1999 to that in 2001?
Your answer should be very brief. 0.97. What is the ratio of the Rent(as % of GDP) in Angola in 1999 to that in 2002?
Make the answer very short. 1.07. What is the ratio of the Rent(as % of GDP) in Malaysia in 1999 to that in 2002?
Provide a succinct answer. 0.82. What is the ratio of the Rent(as % of GDP) of Romania in 1999 to that in 2002?
Give a very brief answer. 0.9. What is the ratio of the Rent(as % of GDP) in Slovak Republic in 1999 to that in 2002?
Your answer should be very brief. 1.14. What is the ratio of the Rent(as % of GDP) of Angola in 2000 to that in 2001?
Ensure brevity in your answer.  1.25. What is the ratio of the Rent(as % of GDP) in Malaysia in 2000 to that in 2001?
Your response must be concise. 1.12. What is the ratio of the Rent(as % of GDP) in Romania in 2000 to that in 2001?
Provide a succinct answer. 1.35. What is the ratio of the Rent(as % of GDP) in Slovak Republic in 2000 to that in 2001?
Offer a terse response. 1.67. What is the ratio of the Rent(as % of GDP) in Angola in 2000 to that in 2002?
Give a very brief answer. 1.42. What is the ratio of the Rent(as % of GDP) of Malaysia in 2000 to that in 2002?
Offer a very short reply. 1.13. What is the ratio of the Rent(as % of GDP) in Romania in 2000 to that in 2002?
Ensure brevity in your answer.  1.55. What is the ratio of the Rent(as % of GDP) in Slovak Republic in 2000 to that in 2002?
Keep it short and to the point. 1.96. What is the ratio of the Rent(as % of GDP) in Angola in 2001 to that in 2002?
Your answer should be compact. 1.14. What is the ratio of the Rent(as % of GDP) of Romania in 2001 to that in 2002?
Ensure brevity in your answer.  1.15. What is the ratio of the Rent(as % of GDP) of Slovak Republic in 2001 to that in 2002?
Keep it short and to the point. 1.17. What is the difference between the highest and the second highest Rent(as % of GDP) in Angola?
Give a very brief answer. 12.62. What is the difference between the highest and the second highest Rent(as % of GDP) in Malaysia?
Give a very brief answer. 0.64. What is the difference between the highest and the second highest Rent(as % of GDP) of Romania?
Offer a terse response. 0.51. What is the difference between the highest and the second highest Rent(as % of GDP) in Slovak Republic?
Make the answer very short. 0. What is the difference between the highest and the lowest Rent(as % of GDP) in Angola?
Provide a succinct answer. 34.22. What is the difference between the highest and the lowest Rent(as % of GDP) of Malaysia?
Provide a succinct answer. 2.36. What is the difference between the highest and the lowest Rent(as % of GDP) of Romania?
Offer a terse response. 1.83. What is the difference between the highest and the lowest Rent(as % of GDP) of Slovak Republic?
Offer a very short reply. 0.02. 